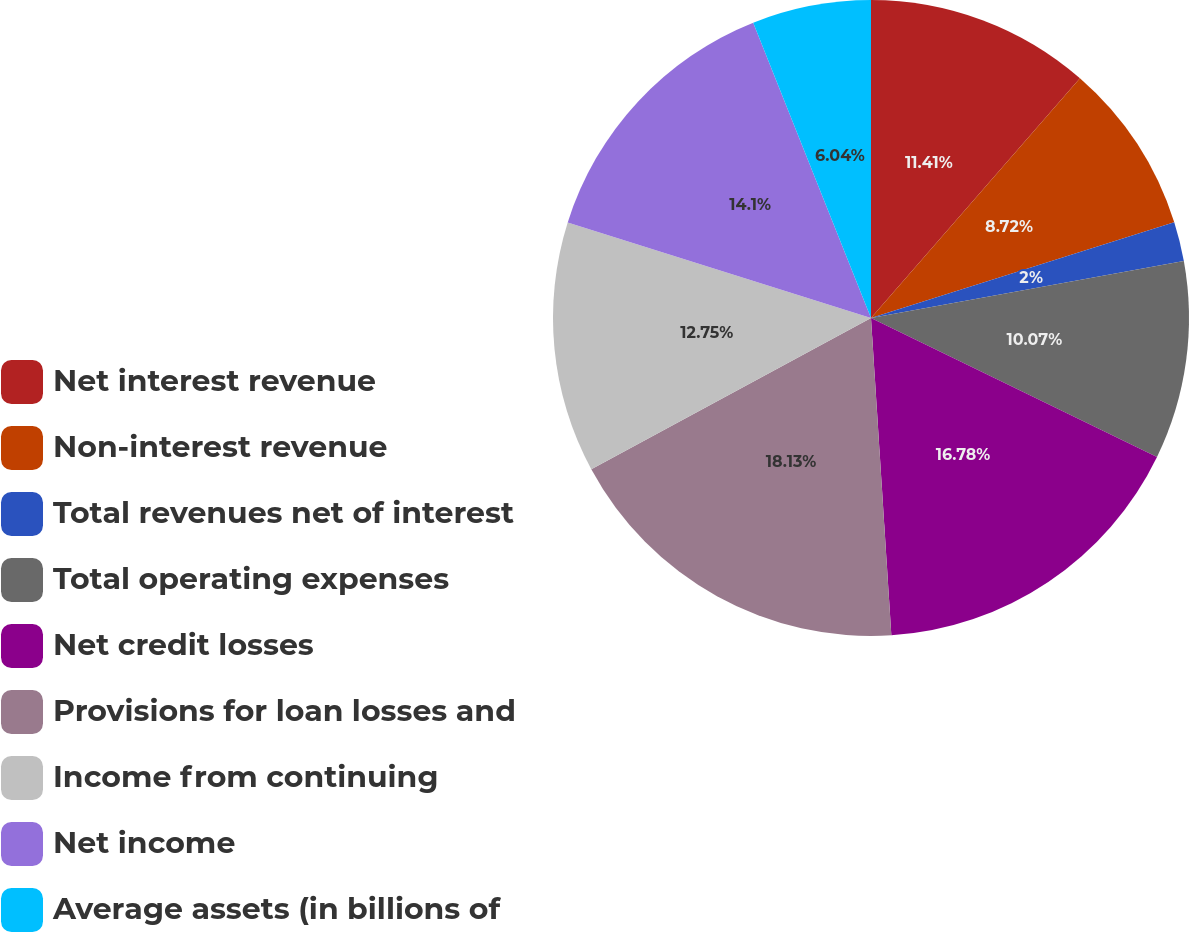Convert chart to OTSL. <chart><loc_0><loc_0><loc_500><loc_500><pie_chart><fcel>Net interest revenue<fcel>Non-interest revenue<fcel>Total revenues net of interest<fcel>Total operating expenses<fcel>Net credit losses<fcel>Provisions for loan losses and<fcel>Income from continuing<fcel>Net income<fcel>Average assets (in billions of<nl><fcel>11.41%<fcel>8.72%<fcel>2.0%<fcel>10.07%<fcel>16.78%<fcel>18.13%<fcel>12.75%<fcel>14.1%<fcel>6.04%<nl></chart> 